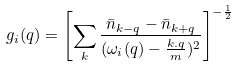Convert formula to latex. <formula><loc_0><loc_0><loc_500><loc_500>g _ { i } ( { q } ) = \left [ \sum _ { k } \frac { { \bar { n } } _ { k - q } - { \bar { n } } _ { k + q } } { ( \omega _ { i } ( { q } ) - \frac { k . q } { m } ) ^ { 2 } } \right ] ^ { - \frac { 1 } { 2 } }</formula> 